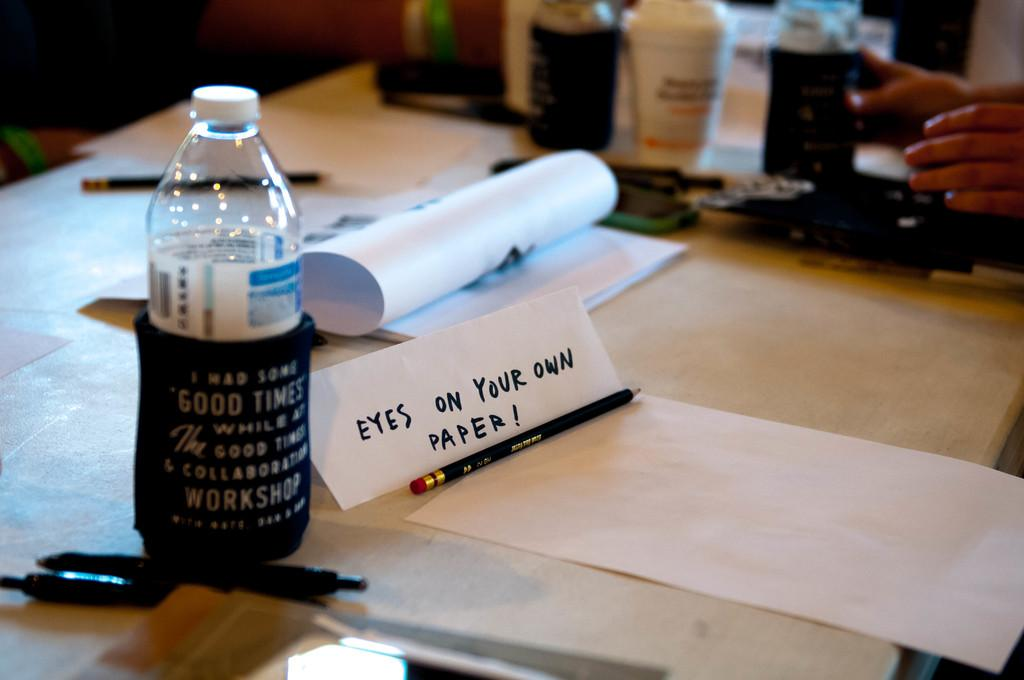<image>
Share a concise interpretation of the image provided. A note reminds someone to keep their eyes on their paper sitting on a desk by a water bottle and empty sheet of paper. 